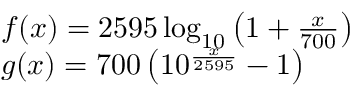Convert formula to latex. <formula><loc_0><loc_0><loc_500><loc_500>\begin{array} { l c l } { f ( x ) = 2 5 9 5 \log _ { 1 0 } \left ( 1 + { \frac { x } { 7 0 0 } } \right ) } \\ { g ( x ) = 7 0 0 \left ( 1 0 ^ { \frac { x } { 2 5 9 5 } } - 1 \right ) } \end{array}</formula> 